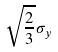Convert formula to latex. <formula><loc_0><loc_0><loc_500><loc_500>\sqrt { \frac { 2 } { 3 } } \sigma _ { y }</formula> 